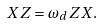<formula> <loc_0><loc_0><loc_500><loc_500>X Z = \omega _ { d } Z X .</formula> 